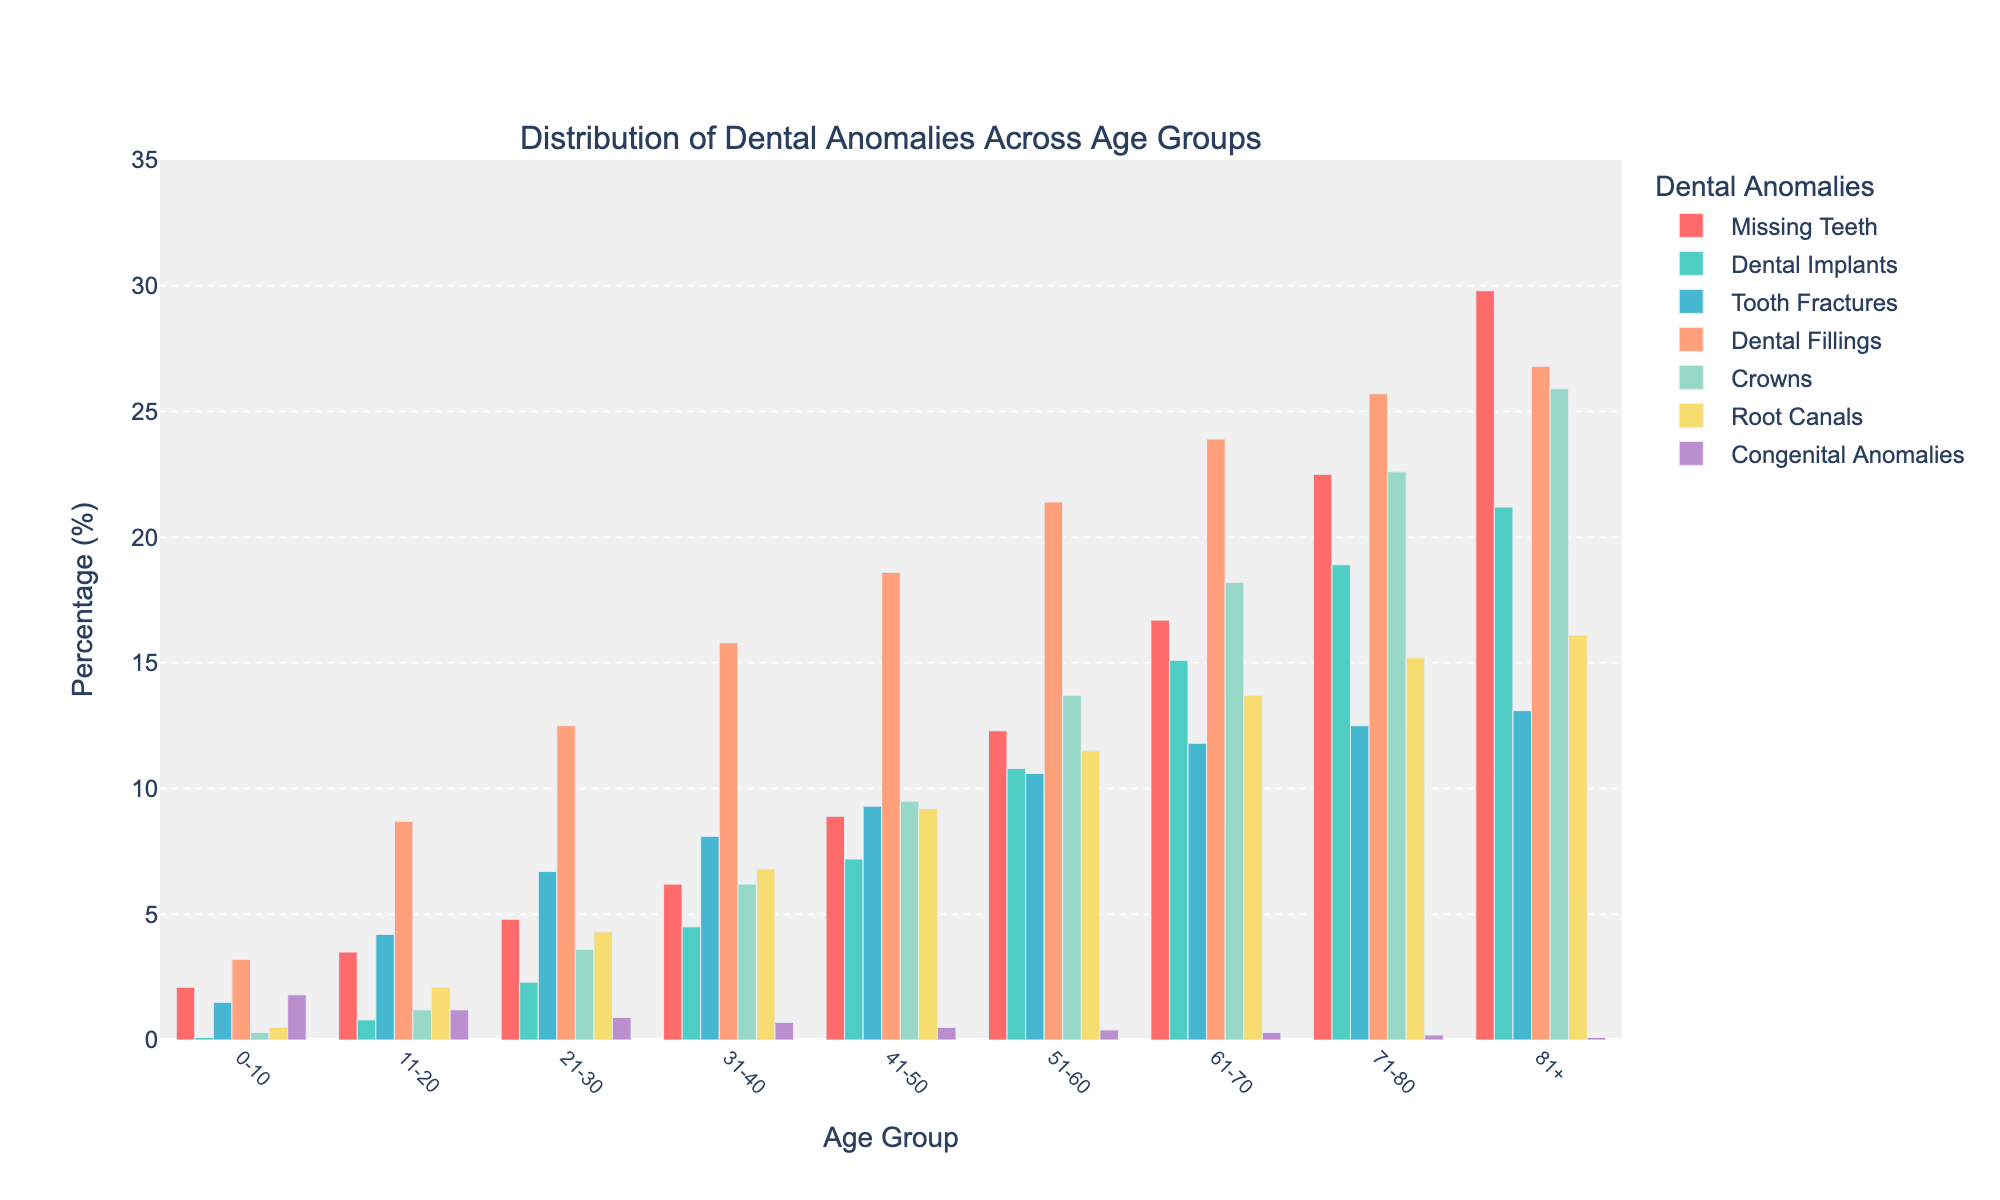What's the most common dental anomaly in the 51-60 age group? Look at the bar heights for the 51-60 age group and compare them. The tallest bar indicates the most common anomaly. Dental Fillings has the highest bar.
Answer: Dental Fillings Which age group has the highest percentage of Root Canals? Look at the bars for Root Canals across all age groups and find the one with the highest value. The 81+ age group has the highest bar.
Answer: 81+ How does the percentage of Dental Fillings change from the 0-10 to the 81+ age group? Examine the bars for Dental Fillings in the 0-10 and 81+ age groups and note their heights. In the 0-10 age group, it's 3.2%, and in the 81+ age group, it's 26.8%. The change is 26.8% - 3.2% = 23.6%.
Answer: Increases by 23.6% Is the percentage of Crowns greater in the 31-40 age group or the 21-30 age group? Compare the bars for Crowns in the 21-30 and 31-40 age groups. The height is higher for the 31-40 age group (6.2%) compared to the 21-30 age group (3.6%).
Answer: 31-40 age group What is the sum of the percentages of Missing Teeth and Dental Implants in the 61-70 age group? Add the percentages of Missing Teeth (16.7%) and Dental Implants (15.1%) in the 61-70 age group. 16.7% + 15.1% = 31.8%.
Answer: 31.8% Which age group has the lowest percentage of Congenital Anomalies? Compare the bars for Congenital Anomalies across all age groups. The 81+ age group has the lowest bar at 0.1%.
Answer: 81+ How does the percentage of Tooth Fractures in the 0-10 age group compare to the 71-80 age group? Look at the bars for Tooth Fractures in the 0-10 and 71-80 age groups. In 0-10, it's 1.5%; in 71-80, it's 12.5%. The percentage in 71-80 is greater.
Answer: 71-80 age group What's the average percentage of Dental Fillings for the age groups 21-30, 31-40, and 41-50? Add the percentages of Dental Fillings for these age groups, then divide by 3. (12.5% + 15.8% + 18.6%) / 3 = 46.9% / 3 ≈ 15.63%.
Answer: 15.63% What is the difference in the percentage of Dental Implants between the 41-50 and 0-10 age groups? Subtract the percentage of Dental Implants in the 0-10 age group from the 41-50 age group. 7.2% - 0.1% = 7.1%.
Answer: 7.1% Which dental anomaly shows the smallest increase in percentage from the 31-40 to the 51-60 age group? Compare the percentages of different anomalies between 31-40 and 51-60. Calculate the difference for each anomaly. Congenital Anomalies shows 0.7% - 0.4% = 0.3% change, which is the smallest increase.
Answer: Congenital Anomalies 